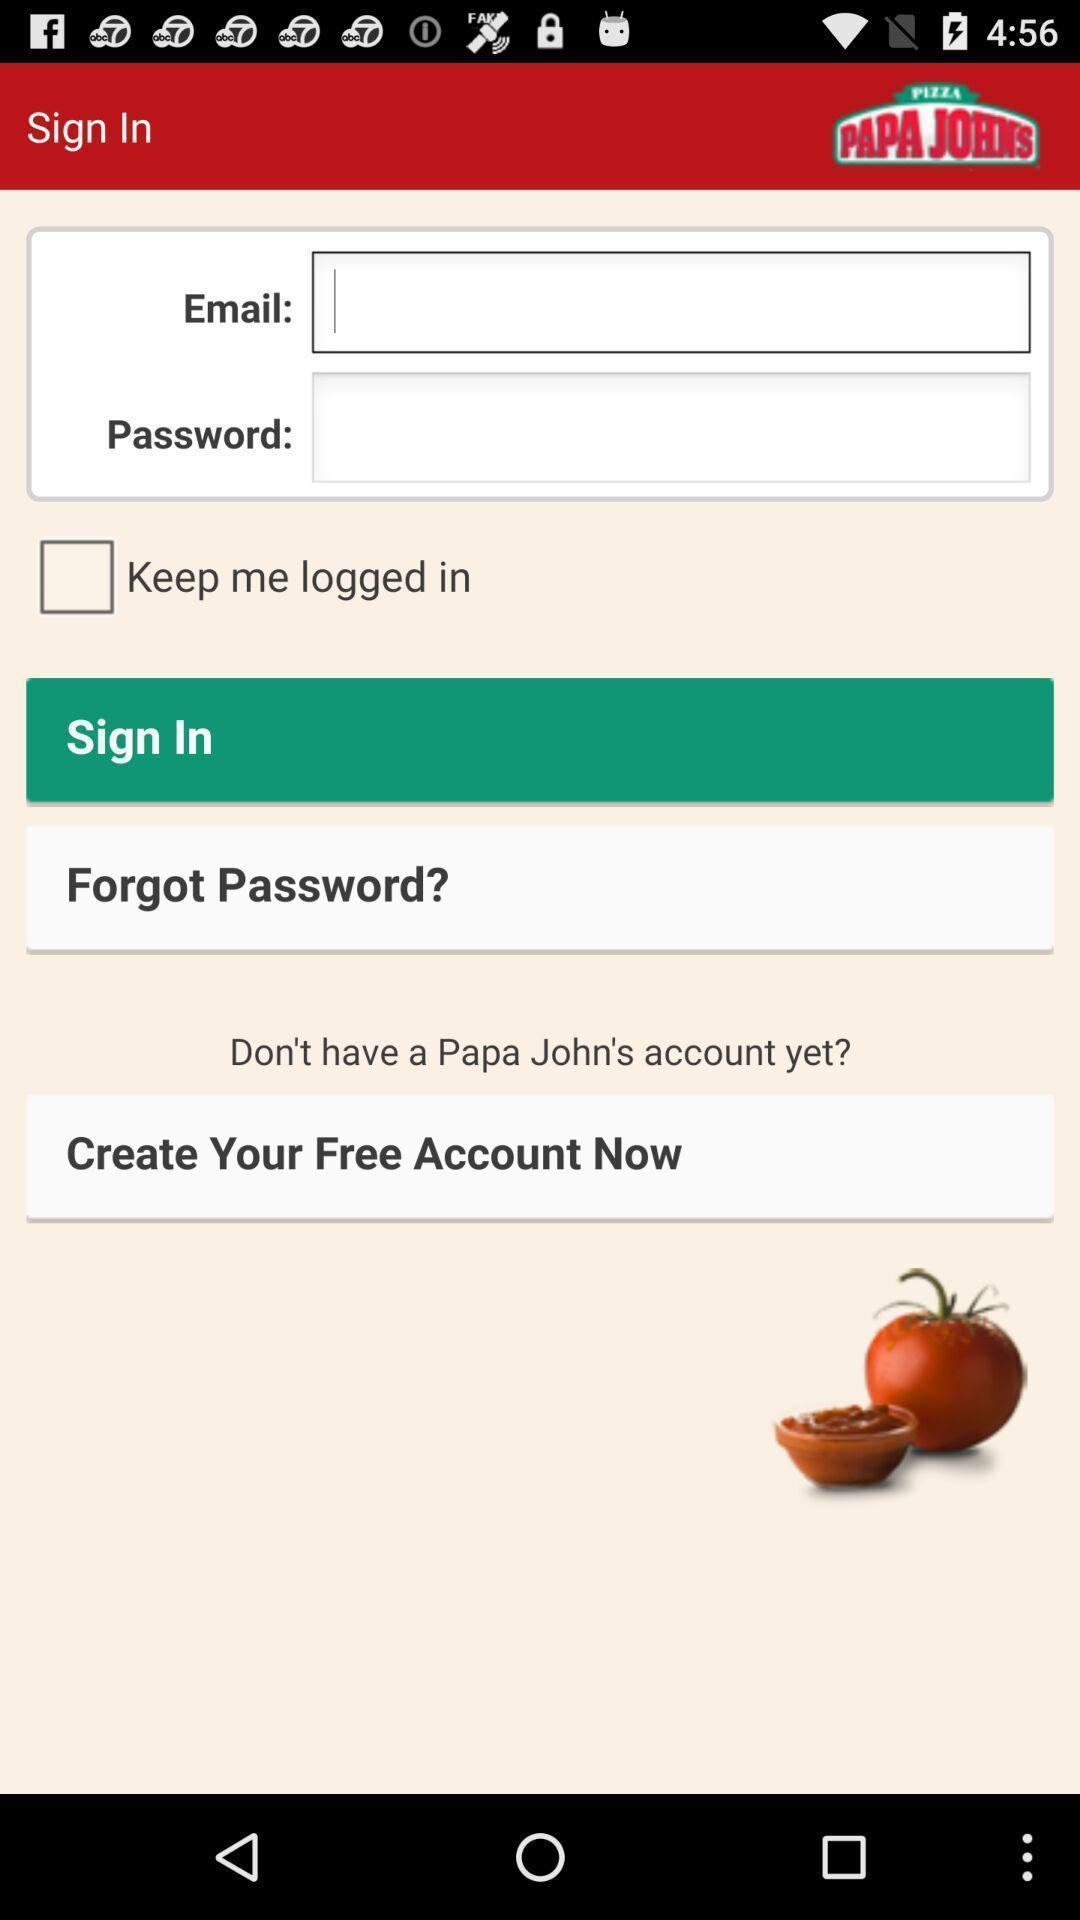What is the overall content of this screenshot? Sign in page with some options in food app. 